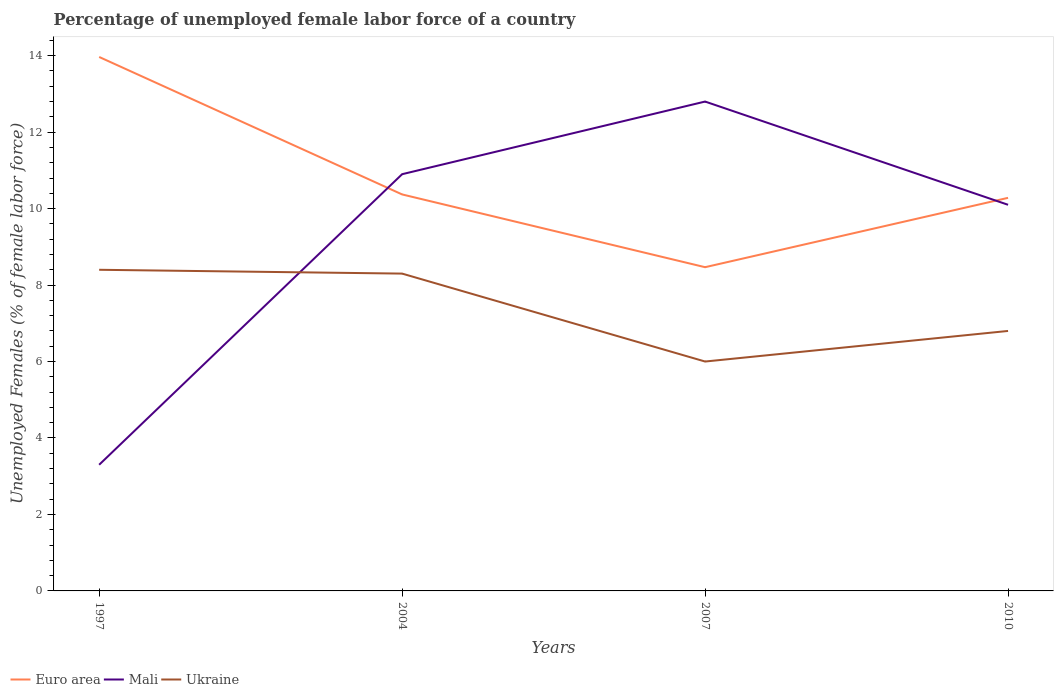Does the line corresponding to Mali intersect with the line corresponding to Ukraine?
Your response must be concise. Yes. Is the number of lines equal to the number of legend labels?
Make the answer very short. Yes. Across all years, what is the maximum percentage of unemployed female labor force in Ukraine?
Your answer should be compact. 6. In which year was the percentage of unemployed female labor force in Mali maximum?
Your answer should be very brief. 1997. What is the total percentage of unemployed female labor force in Ukraine in the graph?
Keep it short and to the point. 1.6. What is the difference between the highest and the second highest percentage of unemployed female labor force in Ukraine?
Provide a short and direct response. 2.4. How many lines are there?
Your answer should be compact. 3. How many years are there in the graph?
Offer a terse response. 4. What is the difference between two consecutive major ticks on the Y-axis?
Your response must be concise. 2. Does the graph contain any zero values?
Offer a terse response. No. What is the title of the graph?
Provide a short and direct response. Percentage of unemployed female labor force of a country. What is the label or title of the X-axis?
Offer a very short reply. Years. What is the label or title of the Y-axis?
Your answer should be very brief. Unemployed Females (% of female labor force). What is the Unemployed Females (% of female labor force) of Euro area in 1997?
Your answer should be compact. 13.97. What is the Unemployed Females (% of female labor force) of Mali in 1997?
Make the answer very short. 3.3. What is the Unemployed Females (% of female labor force) in Ukraine in 1997?
Provide a short and direct response. 8.4. What is the Unemployed Females (% of female labor force) of Euro area in 2004?
Your answer should be very brief. 10.37. What is the Unemployed Females (% of female labor force) in Mali in 2004?
Give a very brief answer. 10.9. What is the Unemployed Females (% of female labor force) of Ukraine in 2004?
Offer a terse response. 8.3. What is the Unemployed Females (% of female labor force) of Euro area in 2007?
Give a very brief answer. 8.47. What is the Unemployed Females (% of female labor force) of Mali in 2007?
Give a very brief answer. 12.8. What is the Unemployed Females (% of female labor force) in Ukraine in 2007?
Provide a short and direct response. 6. What is the Unemployed Females (% of female labor force) in Euro area in 2010?
Your answer should be very brief. 10.28. What is the Unemployed Females (% of female labor force) of Mali in 2010?
Your answer should be compact. 10.1. What is the Unemployed Females (% of female labor force) in Ukraine in 2010?
Ensure brevity in your answer.  6.8. Across all years, what is the maximum Unemployed Females (% of female labor force) in Euro area?
Your answer should be very brief. 13.97. Across all years, what is the maximum Unemployed Females (% of female labor force) in Mali?
Provide a succinct answer. 12.8. Across all years, what is the maximum Unemployed Females (% of female labor force) of Ukraine?
Ensure brevity in your answer.  8.4. Across all years, what is the minimum Unemployed Females (% of female labor force) in Euro area?
Offer a very short reply. 8.47. Across all years, what is the minimum Unemployed Females (% of female labor force) in Mali?
Ensure brevity in your answer.  3.3. Across all years, what is the minimum Unemployed Females (% of female labor force) of Ukraine?
Offer a terse response. 6. What is the total Unemployed Females (% of female labor force) of Euro area in the graph?
Offer a terse response. 43.09. What is the total Unemployed Females (% of female labor force) in Mali in the graph?
Your answer should be very brief. 37.1. What is the total Unemployed Females (% of female labor force) of Ukraine in the graph?
Offer a very short reply. 29.5. What is the difference between the Unemployed Females (% of female labor force) in Euro area in 1997 and that in 2004?
Provide a succinct answer. 3.6. What is the difference between the Unemployed Females (% of female labor force) in Mali in 1997 and that in 2004?
Keep it short and to the point. -7.6. What is the difference between the Unemployed Females (% of female labor force) in Ukraine in 1997 and that in 2004?
Provide a succinct answer. 0.1. What is the difference between the Unemployed Females (% of female labor force) of Euro area in 1997 and that in 2007?
Your response must be concise. 5.5. What is the difference between the Unemployed Females (% of female labor force) in Mali in 1997 and that in 2007?
Make the answer very short. -9.5. What is the difference between the Unemployed Females (% of female labor force) in Euro area in 1997 and that in 2010?
Your response must be concise. 3.68. What is the difference between the Unemployed Females (% of female labor force) of Ukraine in 1997 and that in 2010?
Offer a terse response. 1.6. What is the difference between the Unemployed Females (% of female labor force) in Euro area in 2004 and that in 2007?
Provide a short and direct response. 1.9. What is the difference between the Unemployed Females (% of female labor force) of Ukraine in 2004 and that in 2007?
Keep it short and to the point. 2.3. What is the difference between the Unemployed Females (% of female labor force) of Euro area in 2004 and that in 2010?
Your answer should be very brief. 0.09. What is the difference between the Unemployed Females (% of female labor force) in Mali in 2004 and that in 2010?
Keep it short and to the point. 0.8. What is the difference between the Unemployed Females (% of female labor force) of Euro area in 2007 and that in 2010?
Offer a terse response. -1.81. What is the difference between the Unemployed Females (% of female labor force) of Mali in 2007 and that in 2010?
Offer a very short reply. 2.7. What is the difference between the Unemployed Females (% of female labor force) of Euro area in 1997 and the Unemployed Females (% of female labor force) of Mali in 2004?
Your answer should be compact. 3.07. What is the difference between the Unemployed Females (% of female labor force) of Euro area in 1997 and the Unemployed Females (% of female labor force) of Ukraine in 2004?
Your answer should be compact. 5.67. What is the difference between the Unemployed Females (% of female labor force) of Mali in 1997 and the Unemployed Females (% of female labor force) of Ukraine in 2004?
Your answer should be compact. -5. What is the difference between the Unemployed Females (% of female labor force) of Euro area in 1997 and the Unemployed Females (% of female labor force) of Mali in 2007?
Provide a succinct answer. 1.17. What is the difference between the Unemployed Females (% of female labor force) in Euro area in 1997 and the Unemployed Females (% of female labor force) in Ukraine in 2007?
Your response must be concise. 7.97. What is the difference between the Unemployed Females (% of female labor force) in Mali in 1997 and the Unemployed Females (% of female labor force) in Ukraine in 2007?
Keep it short and to the point. -2.7. What is the difference between the Unemployed Females (% of female labor force) in Euro area in 1997 and the Unemployed Females (% of female labor force) in Mali in 2010?
Provide a succinct answer. 3.87. What is the difference between the Unemployed Females (% of female labor force) of Euro area in 1997 and the Unemployed Females (% of female labor force) of Ukraine in 2010?
Give a very brief answer. 7.17. What is the difference between the Unemployed Females (% of female labor force) in Euro area in 2004 and the Unemployed Females (% of female labor force) in Mali in 2007?
Make the answer very short. -2.43. What is the difference between the Unemployed Females (% of female labor force) of Euro area in 2004 and the Unemployed Females (% of female labor force) of Ukraine in 2007?
Your answer should be very brief. 4.37. What is the difference between the Unemployed Females (% of female labor force) of Mali in 2004 and the Unemployed Females (% of female labor force) of Ukraine in 2007?
Keep it short and to the point. 4.9. What is the difference between the Unemployed Females (% of female labor force) of Euro area in 2004 and the Unemployed Females (% of female labor force) of Mali in 2010?
Ensure brevity in your answer.  0.27. What is the difference between the Unemployed Females (% of female labor force) in Euro area in 2004 and the Unemployed Females (% of female labor force) in Ukraine in 2010?
Your answer should be compact. 3.57. What is the difference between the Unemployed Females (% of female labor force) in Euro area in 2007 and the Unemployed Females (% of female labor force) in Mali in 2010?
Offer a terse response. -1.63. What is the difference between the Unemployed Females (% of female labor force) of Euro area in 2007 and the Unemployed Females (% of female labor force) of Ukraine in 2010?
Your response must be concise. 1.67. What is the average Unemployed Females (% of female labor force) of Euro area per year?
Make the answer very short. 10.77. What is the average Unemployed Females (% of female labor force) of Mali per year?
Provide a short and direct response. 9.28. What is the average Unemployed Females (% of female labor force) of Ukraine per year?
Offer a terse response. 7.38. In the year 1997, what is the difference between the Unemployed Females (% of female labor force) in Euro area and Unemployed Females (% of female labor force) in Mali?
Your answer should be compact. 10.67. In the year 1997, what is the difference between the Unemployed Females (% of female labor force) of Euro area and Unemployed Females (% of female labor force) of Ukraine?
Give a very brief answer. 5.57. In the year 2004, what is the difference between the Unemployed Females (% of female labor force) in Euro area and Unemployed Females (% of female labor force) in Mali?
Ensure brevity in your answer.  -0.53. In the year 2004, what is the difference between the Unemployed Females (% of female labor force) in Euro area and Unemployed Females (% of female labor force) in Ukraine?
Your answer should be compact. 2.07. In the year 2004, what is the difference between the Unemployed Females (% of female labor force) in Mali and Unemployed Females (% of female labor force) in Ukraine?
Give a very brief answer. 2.6. In the year 2007, what is the difference between the Unemployed Females (% of female labor force) in Euro area and Unemployed Females (% of female labor force) in Mali?
Make the answer very short. -4.33. In the year 2007, what is the difference between the Unemployed Females (% of female labor force) in Euro area and Unemployed Females (% of female labor force) in Ukraine?
Provide a succinct answer. 2.47. In the year 2007, what is the difference between the Unemployed Females (% of female labor force) of Mali and Unemployed Females (% of female labor force) of Ukraine?
Your answer should be very brief. 6.8. In the year 2010, what is the difference between the Unemployed Females (% of female labor force) in Euro area and Unemployed Females (% of female labor force) in Mali?
Keep it short and to the point. 0.18. In the year 2010, what is the difference between the Unemployed Females (% of female labor force) of Euro area and Unemployed Females (% of female labor force) of Ukraine?
Provide a short and direct response. 3.48. What is the ratio of the Unemployed Females (% of female labor force) of Euro area in 1997 to that in 2004?
Offer a very short reply. 1.35. What is the ratio of the Unemployed Females (% of female labor force) of Mali in 1997 to that in 2004?
Provide a short and direct response. 0.3. What is the ratio of the Unemployed Females (% of female labor force) in Ukraine in 1997 to that in 2004?
Your answer should be compact. 1.01. What is the ratio of the Unemployed Females (% of female labor force) of Euro area in 1997 to that in 2007?
Provide a short and direct response. 1.65. What is the ratio of the Unemployed Females (% of female labor force) in Mali in 1997 to that in 2007?
Your answer should be compact. 0.26. What is the ratio of the Unemployed Females (% of female labor force) in Ukraine in 1997 to that in 2007?
Your response must be concise. 1.4. What is the ratio of the Unemployed Females (% of female labor force) in Euro area in 1997 to that in 2010?
Provide a short and direct response. 1.36. What is the ratio of the Unemployed Females (% of female labor force) in Mali in 1997 to that in 2010?
Make the answer very short. 0.33. What is the ratio of the Unemployed Females (% of female labor force) of Ukraine in 1997 to that in 2010?
Your response must be concise. 1.24. What is the ratio of the Unemployed Females (% of female labor force) in Euro area in 2004 to that in 2007?
Give a very brief answer. 1.22. What is the ratio of the Unemployed Females (% of female labor force) of Mali in 2004 to that in 2007?
Your answer should be very brief. 0.85. What is the ratio of the Unemployed Females (% of female labor force) of Ukraine in 2004 to that in 2007?
Provide a succinct answer. 1.38. What is the ratio of the Unemployed Females (% of female labor force) in Euro area in 2004 to that in 2010?
Your response must be concise. 1.01. What is the ratio of the Unemployed Females (% of female labor force) of Mali in 2004 to that in 2010?
Your response must be concise. 1.08. What is the ratio of the Unemployed Females (% of female labor force) in Ukraine in 2004 to that in 2010?
Keep it short and to the point. 1.22. What is the ratio of the Unemployed Females (% of female labor force) in Euro area in 2007 to that in 2010?
Provide a succinct answer. 0.82. What is the ratio of the Unemployed Females (% of female labor force) of Mali in 2007 to that in 2010?
Keep it short and to the point. 1.27. What is the ratio of the Unemployed Females (% of female labor force) in Ukraine in 2007 to that in 2010?
Give a very brief answer. 0.88. What is the difference between the highest and the second highest Unemployed Females (% of female labor force) of Euro area?
Offer a very short reply. 3.6. What is the difference between the highest and the second highest Unemployed Females (% of female labor force) of Mali?
Your answer should be very brief. 1.9. What is the difference between the highest and the lowest Unemployed Females (% of female labor force) of Euro area?
Give a very brief answer. 5.5. What is the difference between the highest and the lowest Unemployed Females (% of female labor force) of Ukraine?
Offer a terse response. 2.4. 